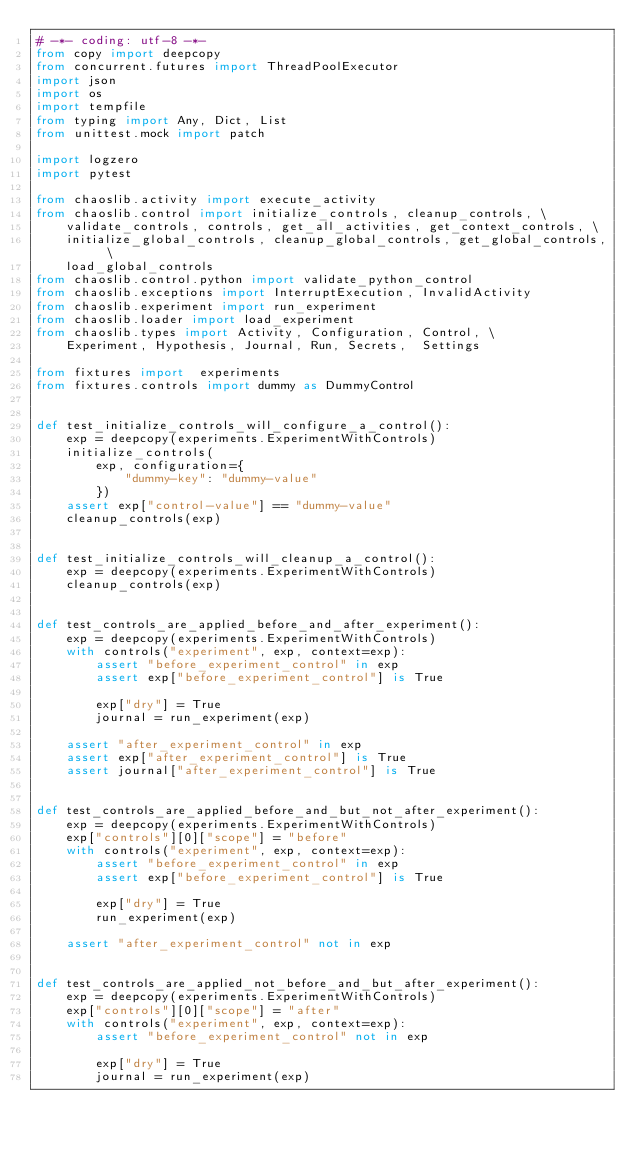<code> <loc_0><loc_0><loc_500><loc_500><_Python_># -*- coding: utf-8 -*-
from copy import deepcopy
from concurrent.futures import ThreadPoolExecutor
import json
import os
import tempfile
from typing import Any, Dict, List
from unittest.mock import patch

import logzero
import pytest

from chaoslib.activity import execute_activity
from chaoslib.control import initialize_controls, cleanup_controls, \
    validate_controls, controls, get_all_activities, get_context_controls, \
    initialize_global_controls, cleanup_global_controls, get_global_controls, \
    load_global_controls
from chaoslib.control.python import validate_python_control
from chaoslib.exceptions import InterruptExecution, InvalidActivity
from chaoslib.experiment import run_experiment
from chaoslib.loader import load_experiment
from chaoslib.types import Activity, Configuration, Control, \
    Experiment, Hypothesis, Journal, Run, Secrets,  Settings

from fixtures import  experiments
from fixtures.controls import dummy as DummyControl


def test_initialize_controls_will_configure_a_control():
    exp = deepcopy(experiments.ExperimentWithControls)
    initialize_controls(
        exp, configuration={
            "dummy-key": "dummy-value"
        })
    assert exp["control-value"] == "dummy-value"
    cleanup_controls(exp)


def test_initialize_controls_will_cleanup_a_control():
    exp = deepcopy(experiments.ExperimentWithControls)
    cleanup_controls(exp)


def test_controls_are_applied_before_and_after_experiment():
    exp = deepcopy(experiments.ExperimentWithControls)
    with controls("experiment", exp, context=exp):
        assert "before_experiment_control" in exp
        assert exp["before_experiment_control"] is True

        exp["dry"] = True
        journal = run_experiment(exp)

    assert "after_experiment_control" in exp
    assert exp["after_experiment_control"] is True
    assert journal["after_experiment_control"] is True


def test_controls_are_applied_before_and_but_not_after_experiment():
    exp = deepcopy(experiments.ExperimentWithControls)
    exp["controls"][0]["scope"] = "before"
    with controls("experiment", exp, context=exp):
        assert "before_experiment_control" in exp
        assert exp["before_experiment_control"] is True

        exp["dry"] = True
        run_experiment(exp)

    assert "after_experiment_control" not in exp


def test_controls_are_applied_not_before_and_but_after_experiment():
    exp = deepcopy(experiments.ExperimentWithControls)
    exp["controls"][0]["scope"] = "after"
    with controls("experiment", exp, context=exp):
        assert "before_experiment_control" not in exp

        exp["dry"] = True
        journal = run_experiment(exp)
</code> 